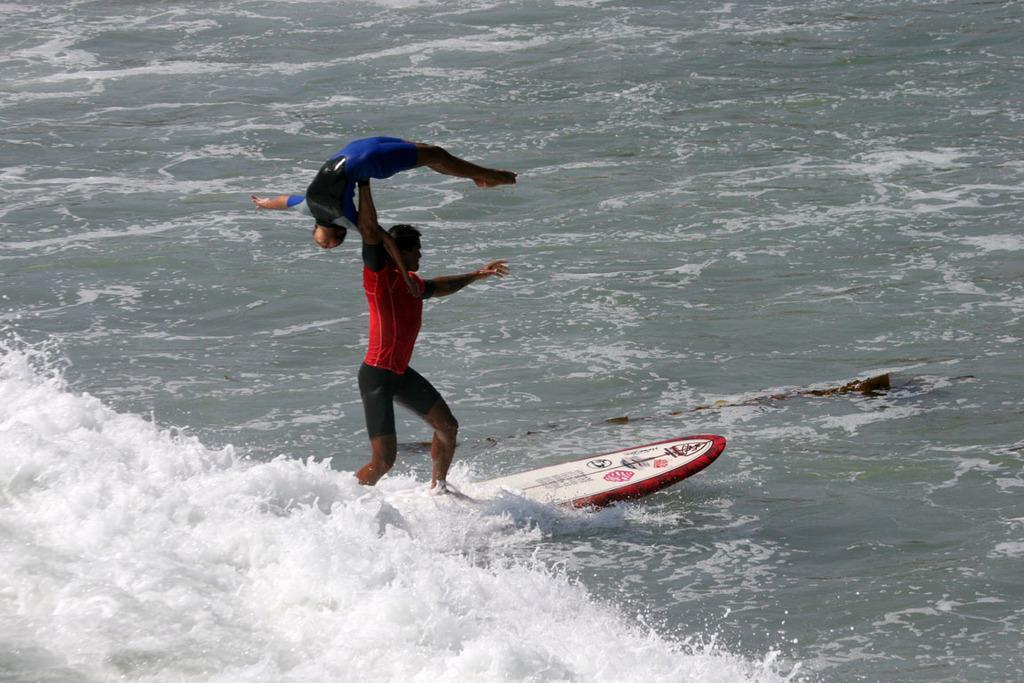Please provide a concise description of this image. In this image we can see water. On the water there is a surfing board. On the surfing board there is a person holding another person and standing. 